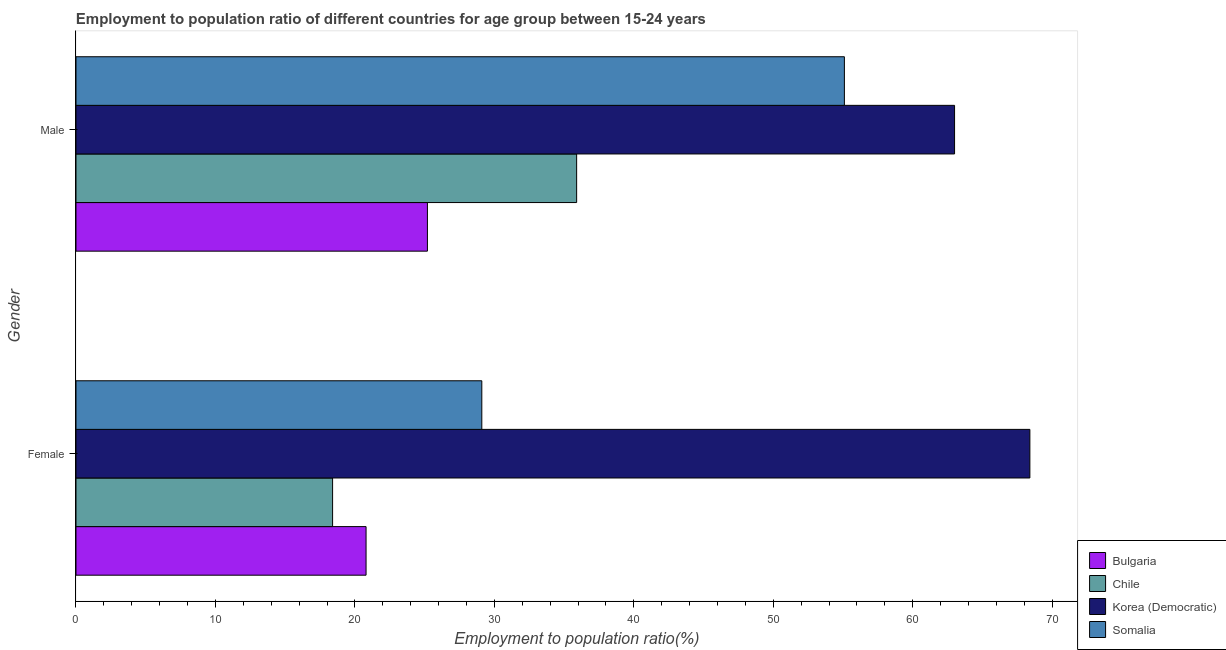How many groups of bars are there?
Your response must be concise. 2. Are the number of bars per tick equal to the number of legend labels?
Your answer should be compact. Yes. How many bars are there on the 1st tick from the top?
Your response must be concise. 4. How many bars are there on the 1st tick from the bottom?
Your answer should be compact. 4. What is the employment to population ratio(female) in Somalia?
Offer a very short reply. 29.1. Across all countries, what is the minimum employment to population ratio(female)?
Provide a short and direct response. 18.4. In which country was the employment to population ratio(female) maximum?
Your answer should be very brief. Korea (Democratic). In which country was the employment to population ratio(female) minimum?
Offer a terse response. Chile. What is the total employment to population ratio(female) in the graph?
Ensure brevity in your answer.  136.7. What is the difference between the employment to population ratio(female) in Korea (Democratic) and that in Somalia?
Make the answer very short. 39.3. What is the difference between the employment to population ratio(female) in Korea (Democratic) and the employment to population ratio(male) in Chile?
Your answer should be compact. 32.5. What is the average employment to population ratio(male) per country?
Offer a terse response. 44.8. What is the difference between the employment to population ratio(male) and employment to population ratio(female) in Somalia?
Provide a succinct answer. 26. In how many countries, is the employment to population ratio(male) greater than 52 %?
Offer a very short reply. 2. What is the ratio of the employment to population ratio(male) in Chile to that in Somalia?
Provide a short and direct response. 0.65. In how many countries, is the employment to population ratio(female) greater than the average employment to population ratio(female) taken over all countries?
Give a very brief answer. 1. What does the 2nd bar from the top in Female represents?
Your answer should be very brief. Korea (Democratic). What does the 4th bar from the bottom in Male represents?
Your response must be concise. Somalia. How many bars are there?
Keep it short and to the point. 8. Are all the bars in the graph horizontal?
Your answer should be very brief. Yes. How many legend labels are there?
Offer a terse response. 4. What is the title of the graph?
Offer a terse response. Employment to population ratio of different countries for age group between 15-24 years. Does "Moldova" appear as one of the legend labels in the graph?
Make the answer very short. No. What is the Employment to population ratio(%) in Bulgaria in Female?
Ensure brevity in your answer.  20.8. What is the Employment to population ratio(%) in Chile in Female?
Your answer should be compact. 18.4. What is the Employment to population ratio(%) of Korea (Democratic) in Female?
Ensure brevity in your answer.  68.4. What is the Employment to population ratio(%) in Somalia in Female?
Provide a short and direct response. 29.1. What is the Employment to population ratio(%) in Bulgaria in Male?
Keep it short and to the point. 25.2. What is the Employment to population ratio(%) of Chile in Male?
Offer a terse response. 35.9. What is the Employment to population ratio(%) of Korea (Democratic) in Male?
Your response must be concise. 63. What is the Employment to population ratio(%) in Somalia in Male?
Ensure brevity in your answer.  55.1. Across all Gender, what is the maximum Employment to population ratio(%) in Bulgaria?
Provide a succinct answer. 25.2. Across all Gender, what is the maximum Employment to population ratio(%) of Chile?
Keep it short and to the point. 35.9. Across all Gender, what is the maximum Employment to population ratio(%) of Korea (Democratic)?
Provide a short and direct response. 68.4. Across all Gender, what is the maximum Employment to population ratio(%) in Somalia?
Offer a terse response. 55.1. Across all Gender, what is the minimum Employment to population ratio(%) of Bulgaria?
Your response must be concise. 20.8. Across all Gender, what is the minimum Employment to population ratio(%) in Chile?
Provide a succinct answer. 18.4. Across all Gender, what is the minimum Employment to population ratio(%) of Somalia?
Offer a terse response. 29.1. What is the total Employment to population ratio(%) in Chile in the graph?
Give a very brief answer. 54.3. What is the total Employment to population ratio(%) in Korea (Democratic) in the graph?
Provide a succinct answer. 131.4. What is the total Employment to population ratio(%) in Somalia in the graph?
Your response must be concise. 84.2. What is the difference between the Employment to population ratio(%) of Chile in Female and that in Male?
Your answer should be compact. -17.5. What is the difference between the Employment to population ratio(%) of Korea (Democratic) in Female and that in Male?
Keep it short and to the point. 5.4. What is the difference between the Employment to population ratio(%) of Bulgaria in Female and the Employment to population ratio(%) of Chile in Male?
Offer a very short reply. -15.1. What is the difference between the Employment to population ratio(%) of Bulgaria in Female and the Employment to population ratio(%) of Korea (Democratic) in Male?
Provide a short and direct response. -42.2. What is the difference between the Employment to population ratio(%) of Bulgaria in Female and the Employment to population ratio(%) of Somalia in Male?
Give a very brief answer. -34.3. What is the difference between the Employment to population ratio(%) in Chile in Female and the Employment to population ratio(%) in Korea (Democratic) in Male?
Make the answer very short. -44.6. What is the difference between the Employment to population ratio(%) of Chile in Female and the Employment to population ratio(%) of Somalia in Male?
Offer a terse response. -36.7. What is the average Employment to population ratio(%) in Chile per Gender?
Your answer should be very brief. 27.15. What is the average Employment to population ratio(%) in Korea (Democratic) per Gender?
Offer a terse response. 65.7. What is the average Employment to population ratio(%) of Somalia per Gender?
Your answer should be compact. 42.1. What is the difference between the Employment to population ratio(%) of Bulgaria and Employment to population ratio(%) of Korea (Democratic) in Female?
Your answer should be compact. -47.6. What is the difference between the Employment to population ratio(%) of Chile and Employment to population ratio(%) of Korea (Democratic) in Female?
Give a very brief answer. -50. What is the difference between the Employment to population ratio(%) of Korea (Democratic) and Employment to population ratio(%) of Somalia in Female?
Your answer should be very brief. 39.3. What is the difference between the Employment to population ratio(%) of Bulgaria and Employment to population ratio(%) of Korea (Democratic) in Male?
Make the answer very short. -37.8. What is the difference between the Employment to population ratio(%) in Bulgaria and Employment to population ratio(%) in Somalia in Male?
Your answer should be very brief. -29.9. What is the difference between the Employment to population ratio(%) of Chile and Employment to population ratio(%) of Korea (Democratic) in Male?
Provide a short and direct response. -27.1. What is the difference between the Employment to population ratio(%) in Chile and Employment to population ratio(%) in Somalia in Male?
Your answer should be compact. -19.2. What is the difference between the Employment to population ratio(%) in Korea (Democratic) and Employment to population ratio(%) in Somalia in Male?
Give a very brief answer. 7.9. What is the ratio of the Employment to population ratio(%) in Bulgaria in Female to that in Male?
Provide a short and direct response. 0.83. What is the ratio of the Employment to population ratio(%) in Chile in Female to that in Male?
Give a very brief answer. 0.51. What is the ratio of the Employment to population ratio(%) in Korea (Democratic) in Female to that in Male?
Your answer should be very brief. 1.09. What is the ratio of the Employment to population ratio(%) in Somalia in Female to that in Male?
Ensure brevity in your answer.  0.53. What is the difference between the highest and the second highest Employment to population ratio(%) of Somalia?
Provide a short and direct response. 26. 